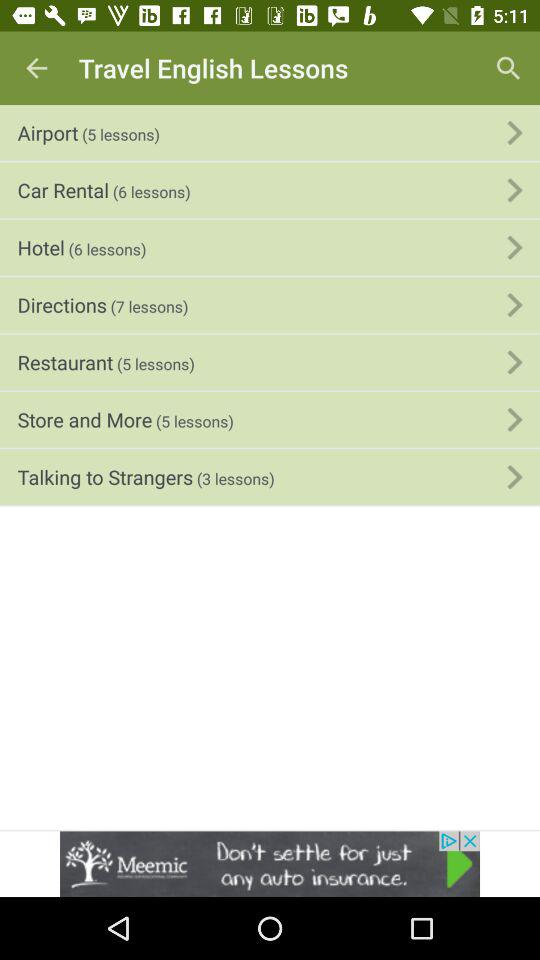How many lessons are in the Store and More section?
Answer the question using a single word or phrase. 5 